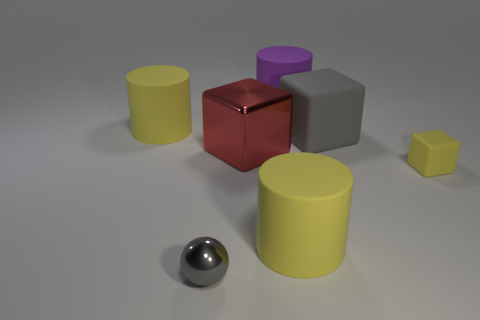How many other large red objects are the same shape as the big red metallic object? 0 